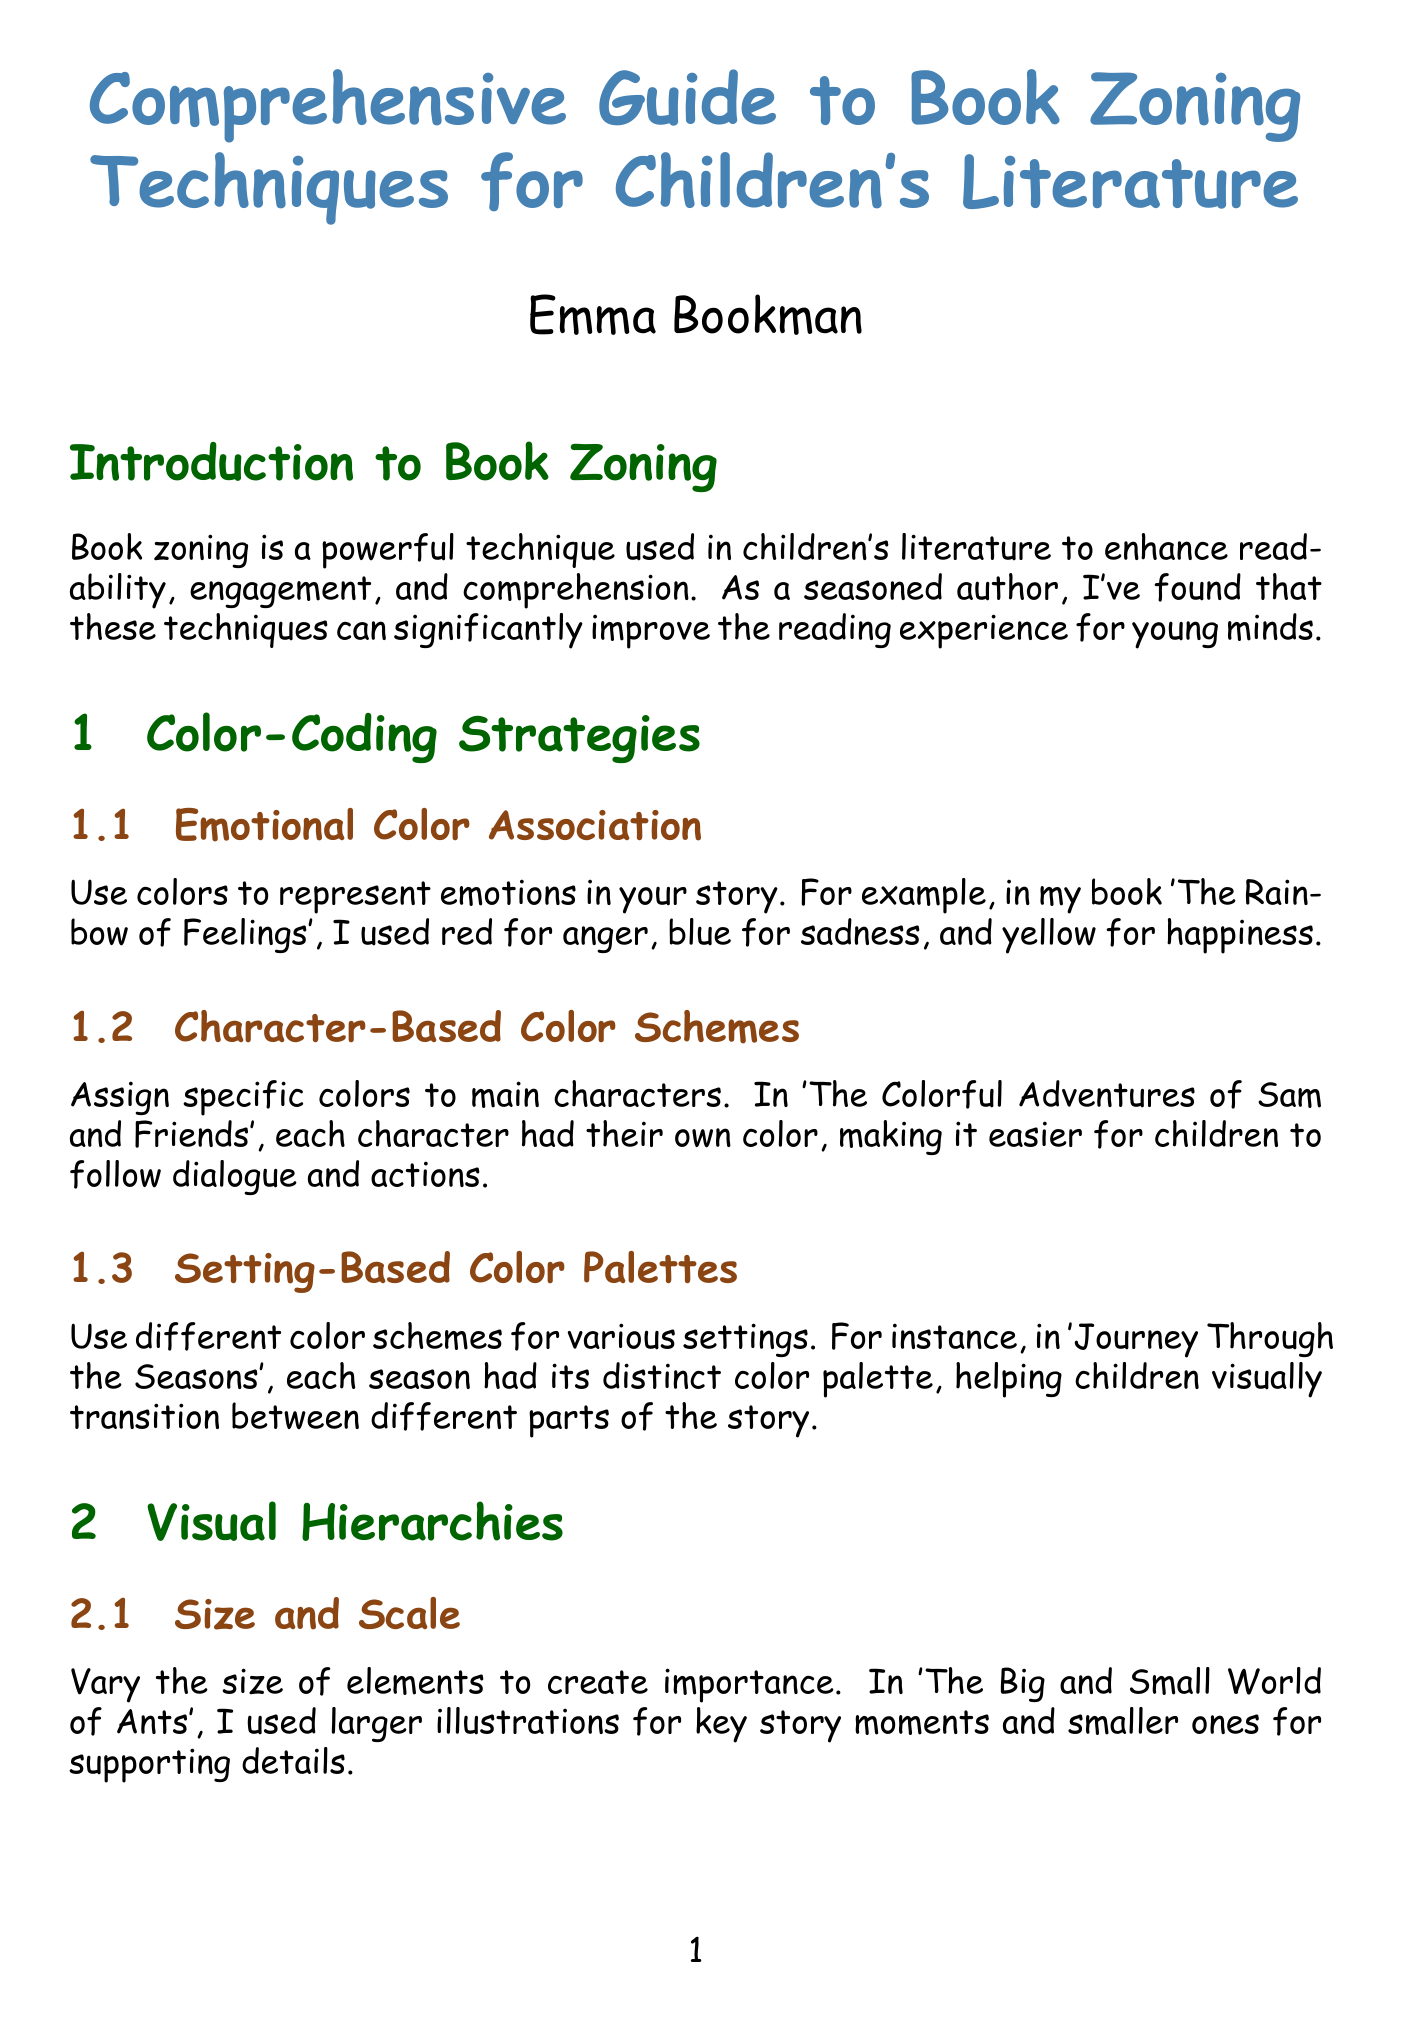what is the title of the guide? The title of the guide is provided at the beginning of the document, which is "Comprehensive Guide to Book Zoning Techniques for Children's Literature."
Answer: Comprehensive Guide to Book Zoning Techniques for Children's Literature who is the author of the guide? The author's name is mentioned on the title page of the document.
Answer: Emma Bookman name one case study mentioned in the document. The document lists several case studies under the "Case Studies" section, and one example is provided.
Answer: The Gruffalo by Julia Donaldson what is the focus of the "Color-Coding Strategies" section? This section discusses different methods of using color to enhance children's literature through various associations.
Answer: Color-coding strategies which book uses size and scale for visual hierarchies? The text provides an example from a specific book where size is used to convey importance within the illustrations.
Answer: The Big and Small World of Ants how can typography influence reading skills according to the document? The document outlines how adjustments in typography, including text size and spacing, can be made to match the evolving reading skills of children.
Answer: Growing Words what is emphasized in the "Integrating Zoning Techniques" section? This section emphasizes the combination of different zoning techniques to create a cohesive reading experience in children's books.
Answer: Cohesive reading experience name one emotional color association used in a book mentioned. The document cites a specific example where a color is used to represent a particular emotion in a children's book.
Answer: Red for anger what practical implementation tip is provided in the document? The guide offers several tips regarding the implementation of zoning techniques, with emphasis on starting with a clear plan.
Answer: Start with a clear plan which font is recommended for early readers in typographic strategies? The document specifies a particular font that is well-suited for early readers in a dedicated subsection on font selection.
Answer: Sassoon Primary 